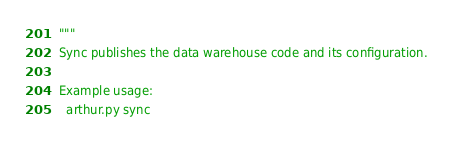<code> <loc_0><loc_0><loc_500><loc_500><_Python_>"""
Sync publishes the data warehouse code and its configuration.

Example usage:
  arthur.py sync</code> 